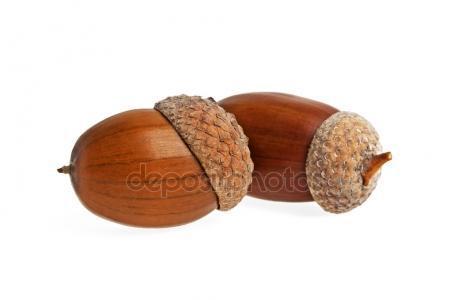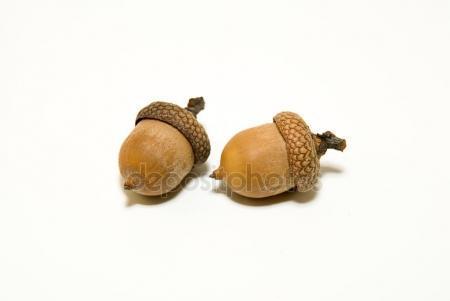The first image is the image on the left, the second image is the image on the right. Evaluate the accuracy of this statement regarding the images: "There are four acorns in total.". Is it true? Answer yes or no. Yes. 